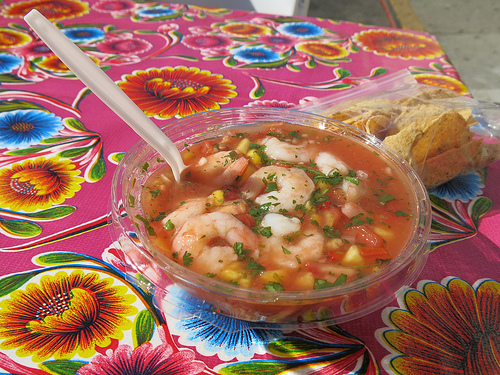<image>
Can you confirm if the flower is under the soup? Yes. The flower is positioned underneath the soup, with the soup above it in the vertical space. Where is the food in relation to the bowl? Is it in the bowl? No. The food is not contained within the bowl. These objects have a different spatial relationship. 